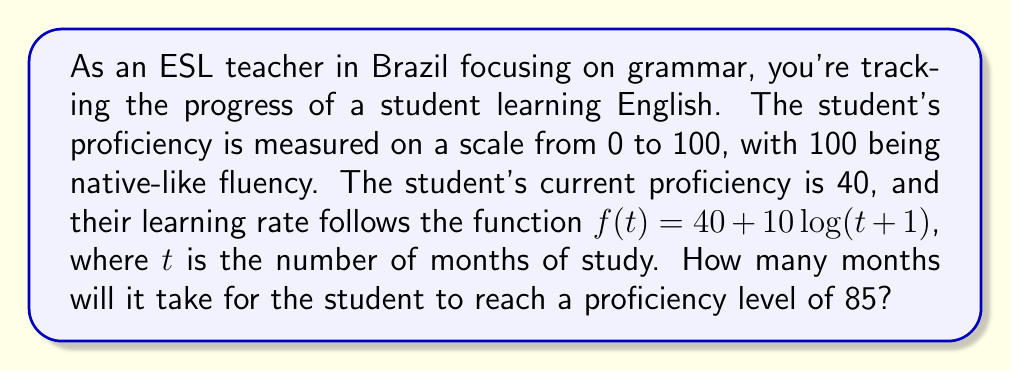Solve this math problem. To solve this problem, we need to follow these steps:

1) We start with the given function: $f(t) = 40 + 10\log(t+1)$

2) We want to find $t$ when $f(t) = 85$. So, we set up the equation:

   $85 = 40 + 10\log(t+1)$

3) Subtract 40 from both sides:

   $45 = 10\log(t+1)$

4) Divide both sides by 10:

   $4.5 = \log(t+1)$

5) To solve for $t$, we need to apply the inverse function of $\log$, which is $e^x$:

   $e^{4.5} = t+1$

6) Subtract 1 from both sides:

   $e^{4.5} - 1 = t$

7) Calculate the value:

   $t = e^{4.5} - 1 \approx 89.0166 - 1 = 88.0166$

8) Since we're dealing with months, we need to round up to the nearest whole number.
Answer: It will take 89 months for the student to reach a proficiency level of 85. 